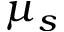Convert formula to latex. <formula><loc_0><loc_0><loc_500><loc_500>\mu _ { s }</formula> 